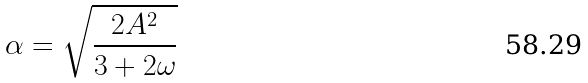Convert formula to latex. <formula><loc_0><loc_0><loc_500><loc_500>\alpha = \sqrt { \frac { 2 A ^ { 2 } } { 3 + 2 \omega } }</formula> 